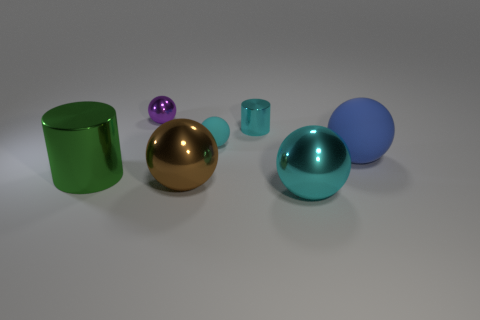The objects appear to be placed deliberately. What might be the purpose of this arrangement? The deliberate placement suggests a composition designed to showcase diversity in color and form, perhaps for a visual comparison, an aesthetic display, or to illustrate principles of photography such as depth, focus, and perspective. 